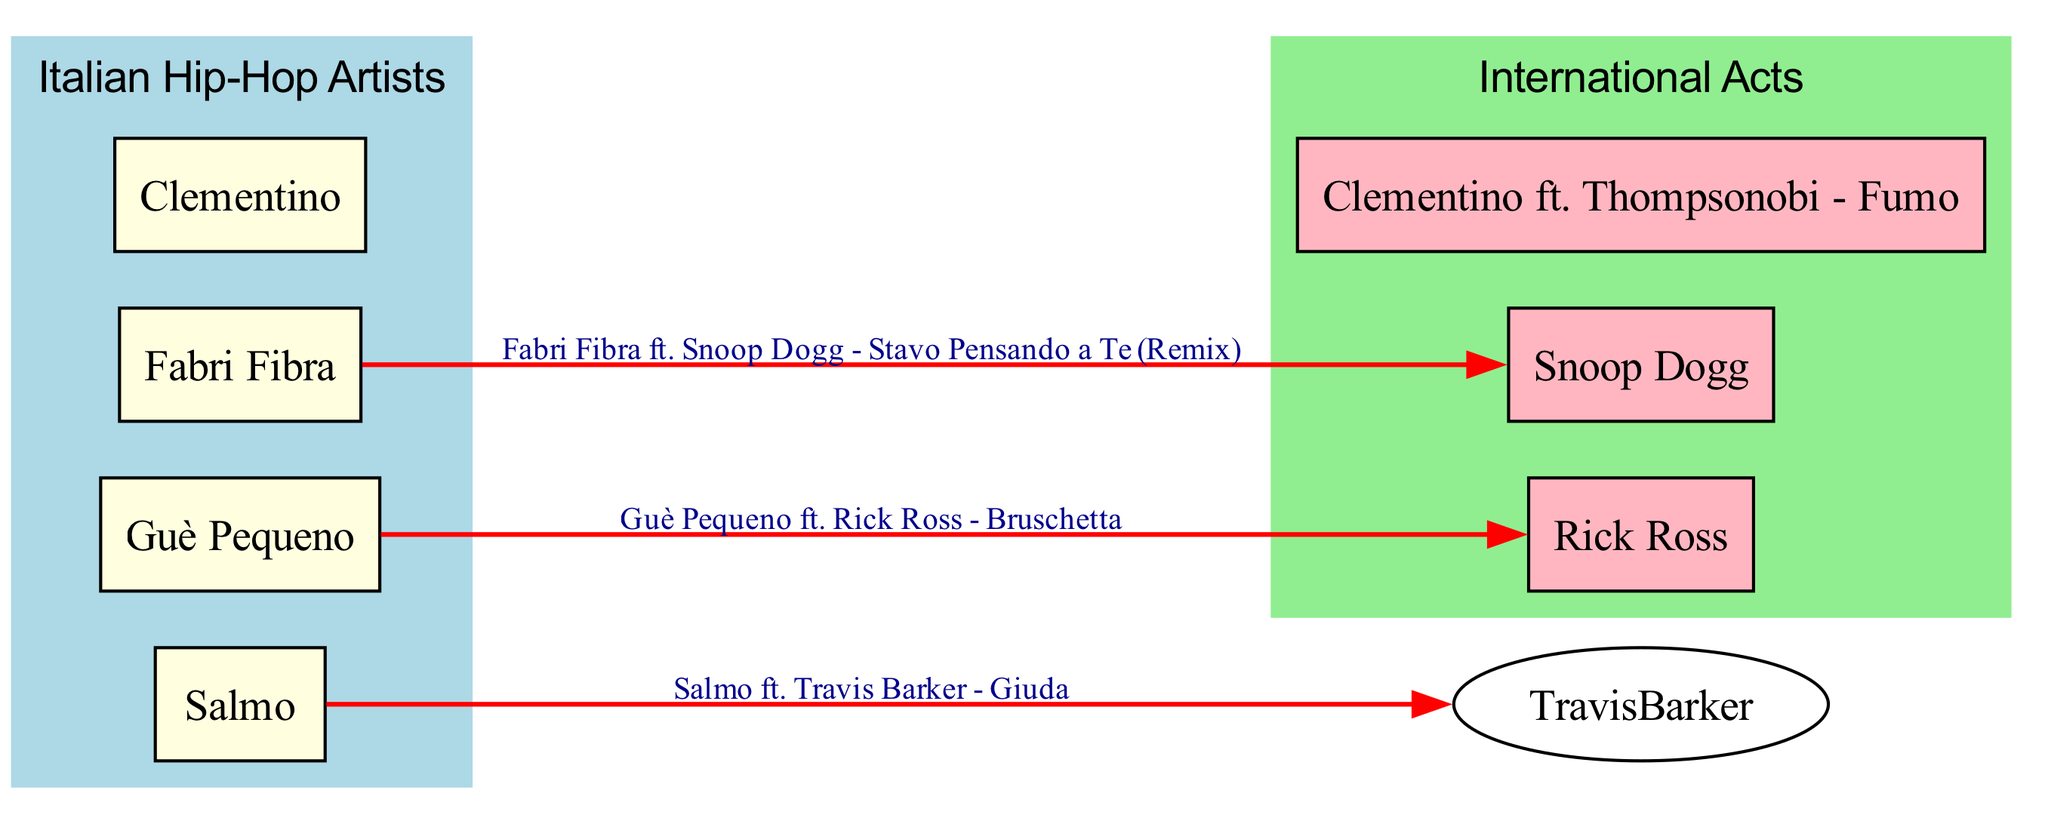What are the names of the Italian Hip-Hop artists in the diagram? The diagram lists Fabri Fibra, Guè Pequeno, Salmo, and Clementino under the "Italian Hip-Hop Artists" category.
Answer: Fabri Fibra, Guè Pequeno, Salmo, Clementino How many collaborations are shown between Italian artists and international acts? By examining the edges in the diagram, we see there are four collaborations connecting Italian artists with international acts.
Answer: Four Which international act collaborated with Guè Pequeno? The diagram indicates that Guè Pequeno collaborated with Rick Ross, as represented by the edge connecting them.
Answer: Rick Ross Which song features Fabri Fibra and Snoop Dogg? The edge between Fabri Fibra and Snoop Dogg in the diagram is labeled "Fabri Fibra ft. Snoop Dogg - Stavo Pensando a Te (Remix)," indicating the collaboration.
Answer: Stavo Pensando a Te (Remix) What is the connection between Salmo and Travis Barker? The diagram shows a directed edge from Salmo to Travis Barker labeled "Salmo ft. Travis Barker - Giuda," indicating their collaboration.
Answer: Giuda Which Italian artist has the most collaborations listed with international acts? The diagram does not show any specific artist having more than one collaboration listed with an international act, as all listed artists have exactly one collaboration shown each.
Answer: None Name one collaboration involving Clementino. The diagram illustrates one collaboration for Clementino, which is "Clementino ft. Thompsonobi - Fumo," shown by the edge connecting them.
Answer: Fumo What type of diagram is this? The structure of the diagram, with nodes representing artists and edges representing collaborations, characterizes it as a concept map focused on key collaborations.
Answer: Concept map 